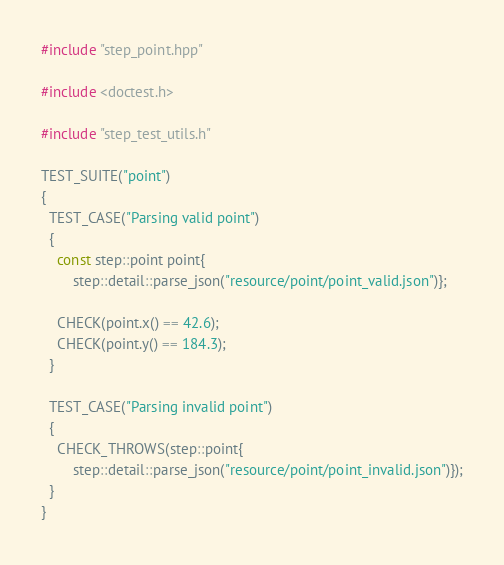<code> <loc_0><loc_0><loc_500><loc_500><_C++_>#include "step_point.hpp"

#include <doctest.h>

#include "step_test_utils.h"

TEST_SUITE("point")
{
  TEST_CASE("Parsing valid point")
  {
    const step::point point{
        step::detail::parse_json("resource/point/point_valid.json")};

    CHECK(point.x() == 42.6);
    CHECK(point.y() == 184.3);
  }

  TEST_CASE("Parsing invalid point")
  {
    CHECK_THROWS(step::point{
        step::detail::parse_json("resource/point/point_invalid.json")});
  }
}
</code> 